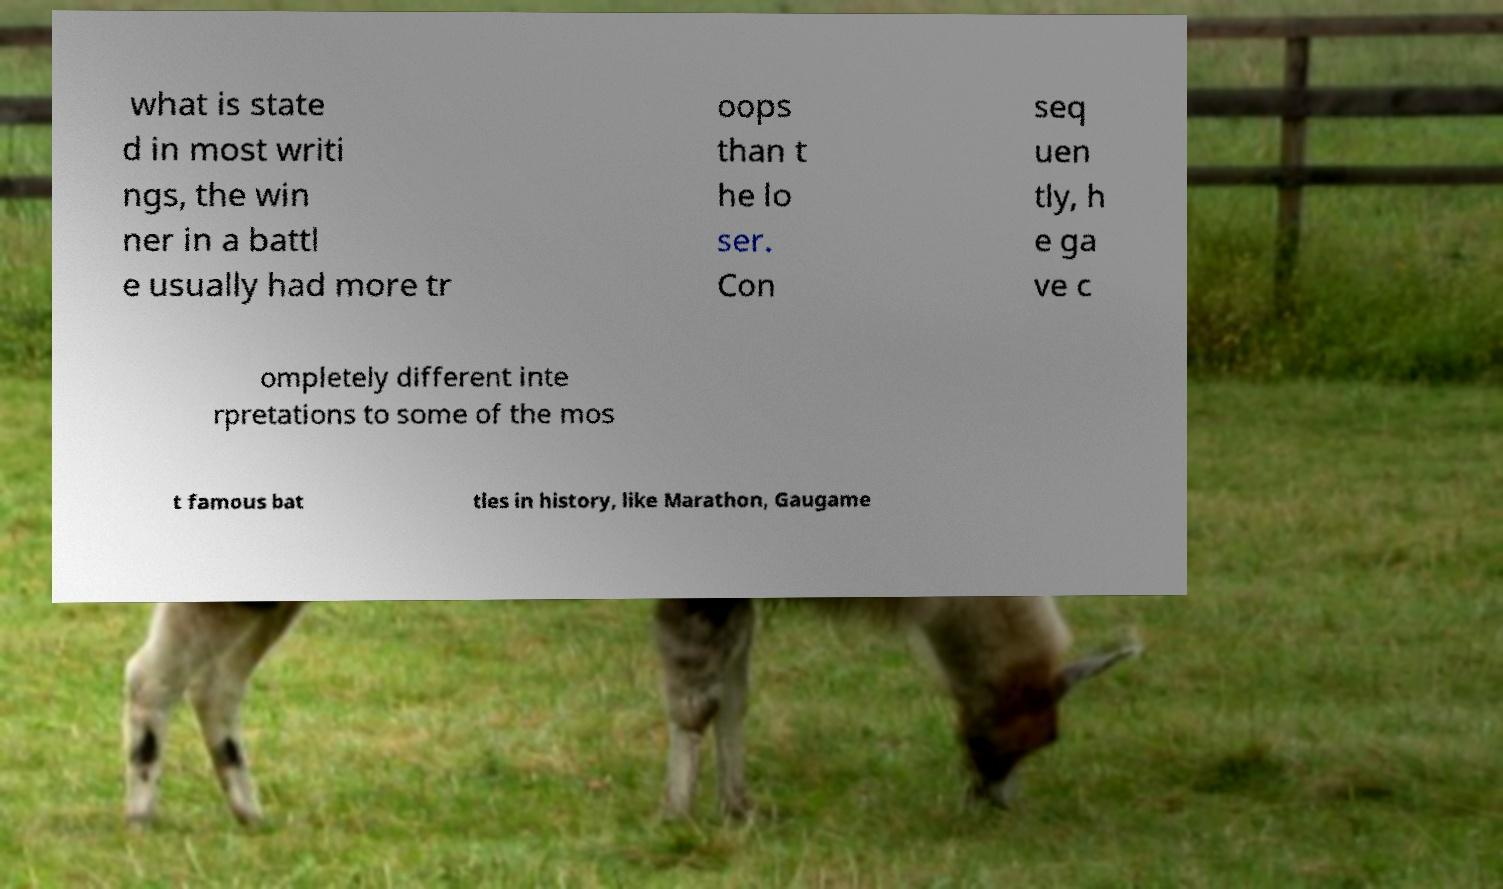Could you extract and type out the text from this image? what is state d in most writi ngs, the win ner in a battl e usually had more tr oops than t he lo ser. Con seq uen tly, h e ga ve c ompletely different inte rpretations to some of the mos t famous bat tles in history, like Marathon, Gaugame 